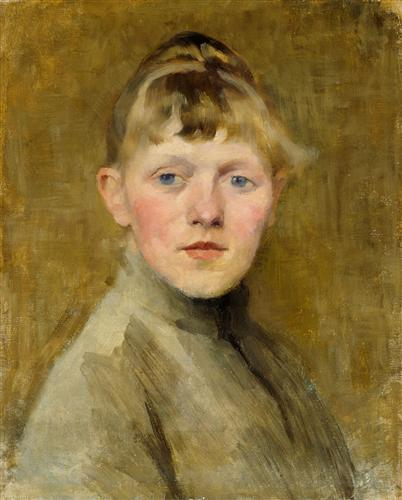Can you discuss the artistic techniques used in this painting and how they contribute to the overall expression? The artist has skillfully employed impressionistic techniques, characterized by loose and fluid brush strokes that capture the essence rather than the minutiae of the subject. The brushwork adds a dreamy, almost ethereal quality to the portrait, emphasizing the transient beauty of youth. The choice of a muted palette, primarily consisting of soft grays and warm yellows, directs the viewer’s focus to the boy’s face, particularly his expressive eyes and the subtle hues of his hair. This technique not only highlights the physical features of the boy but also evokes a sense of intimacy and depth, inviting the viewer to connect emotionally with the subject. 